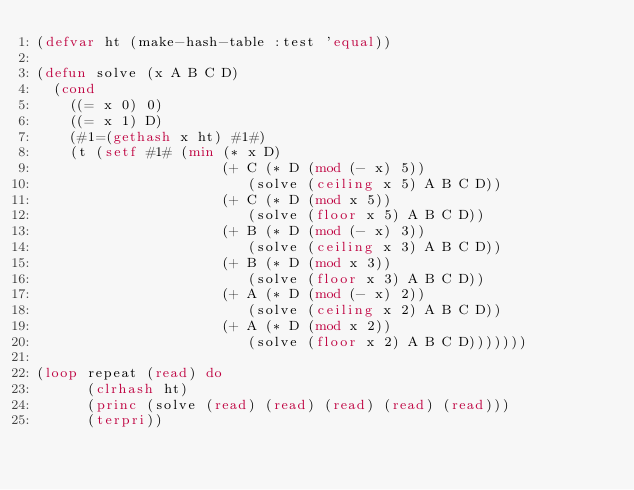<code> <loc_0><loc_0><loc_500><loc_500><_Lisp_>(defvar ht (make-hash-table :test 'equal))

(defun solve (x A B C D)
  (cond 
    ((= x 0) 0)
    ((= x 1) D)
    (#1=(gethash x ht) #1#)
    (t (setf #1# (min (* x D)
                      (+ C (* D (mod (- x) 5))
                         (solve (ceiling x 5) A B C D))
                      (+ C (* D (mod x 5))
                         (solve (floor x 5) A B C D))
                      (+ B (* D (mod (- x) 3))
                         (solve (ceiling x 3) A B C D))
                      (+ B (* D (mod x 3))
                         (solve (floor x 3) A B C D))
                      (+ A (* D (mod (- x) 2))
                         (solve (ceiling x 2) A B C D))
                      (+ A (* D (mod x 2))
                         (solve (floor x 2) A B C D)))))))

(loop repeat (read) do
      (clrhash ht)
      (princ (solve (read) (read) (read) (read) (read)))
      (terpri))

</code> 